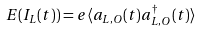<formula> <loc_0><loc_0><loc_500><loc_500>E ( I _ { L } ( t ) ) = e \langle a _ { L , O } ( t ) a _ { L , O } ^ { \dagger } ( t ) \rangle</formula> 